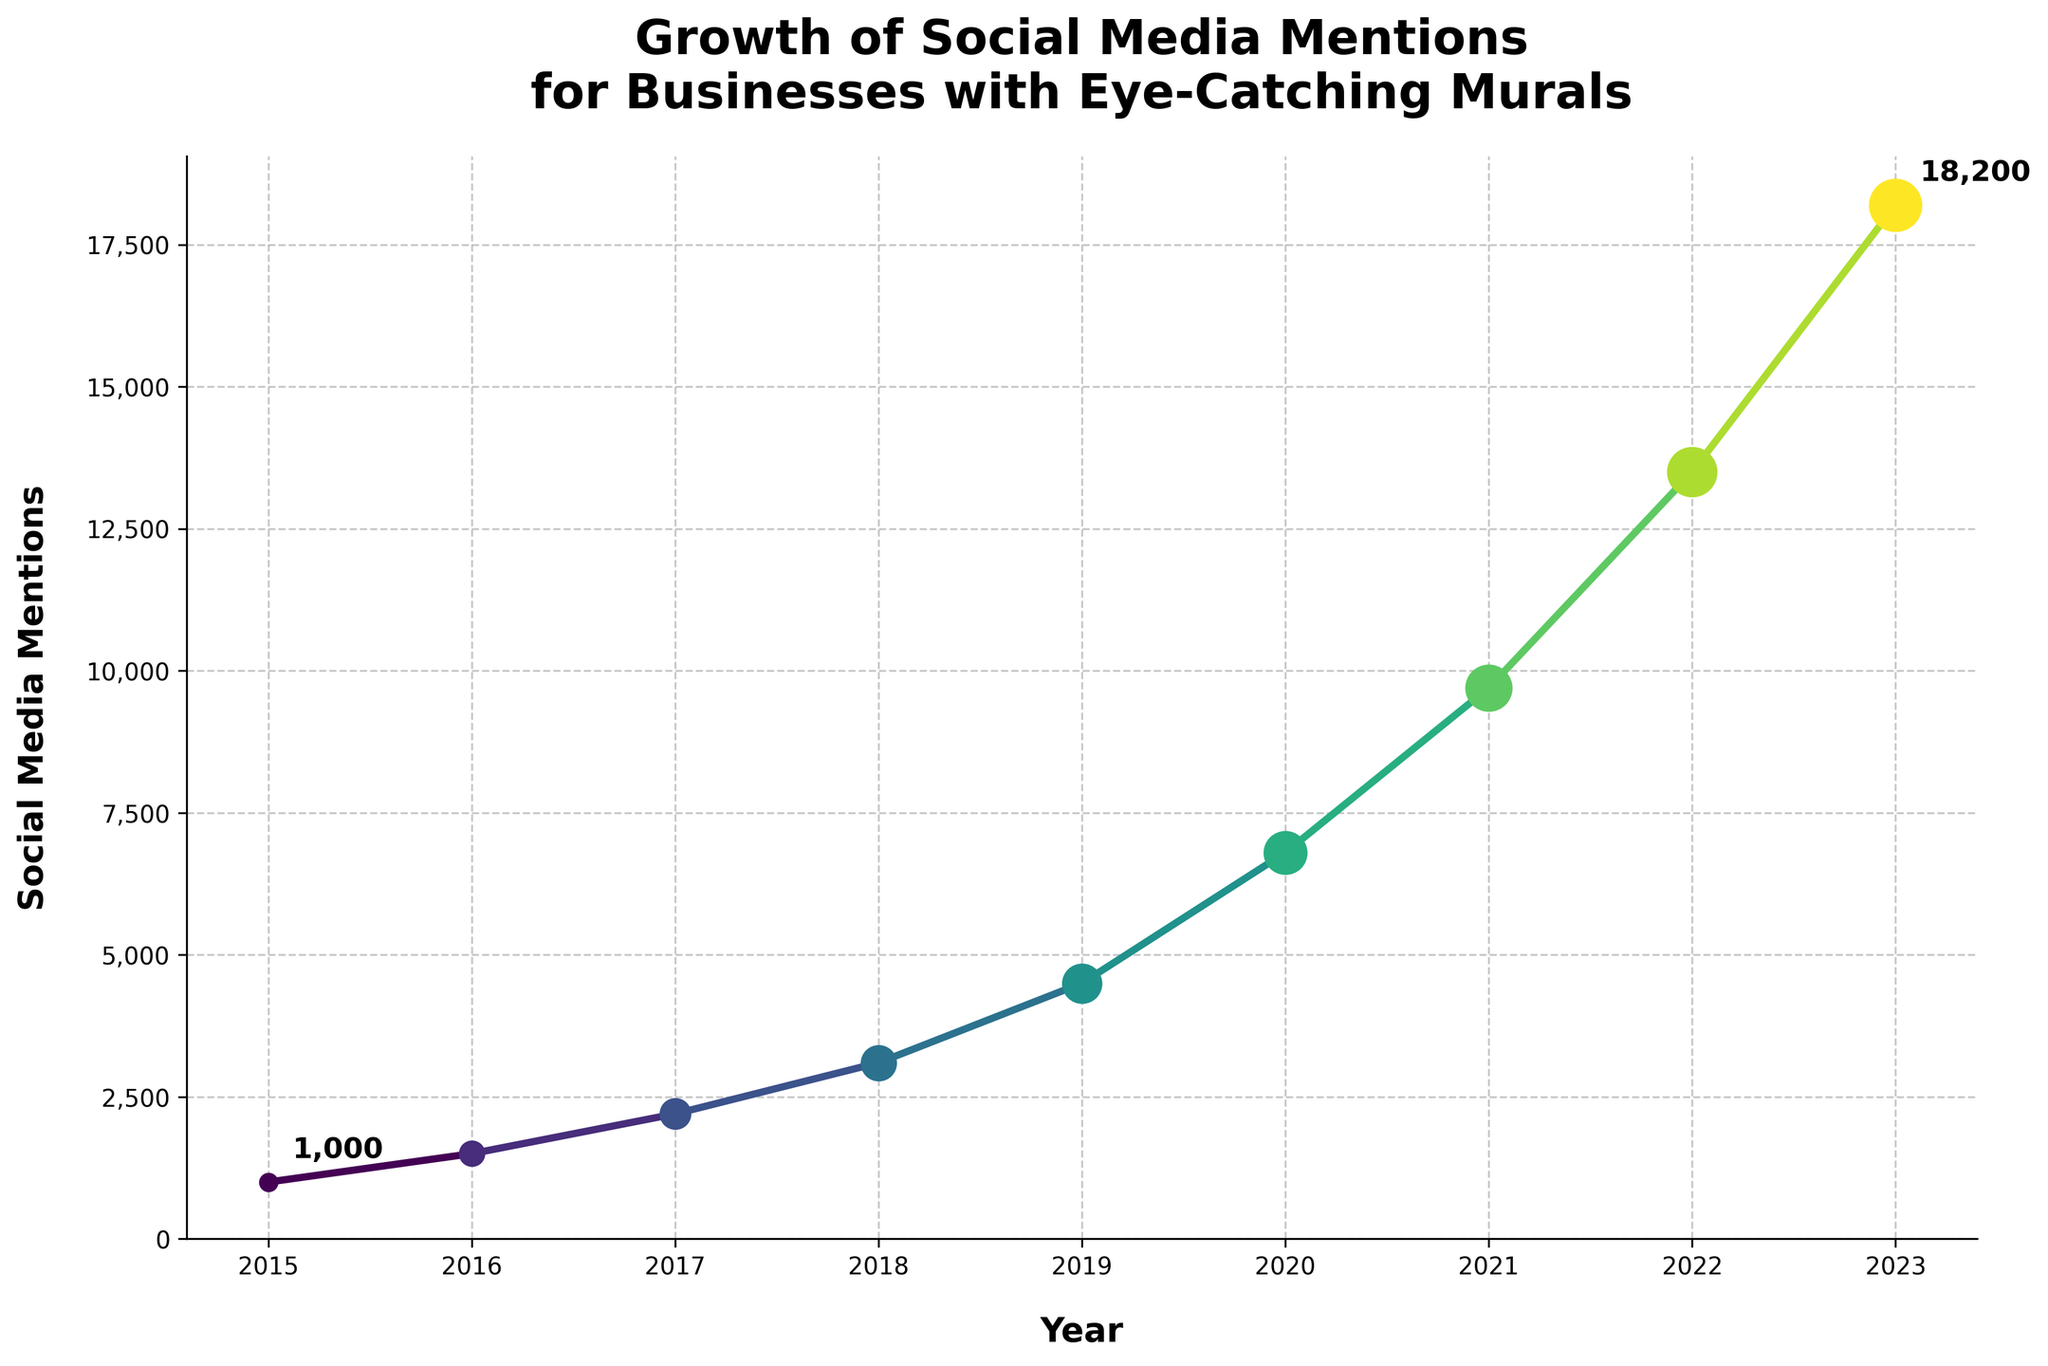What is the overall trend of social media mentions for businesses with eye-catching murals from 2015 to 2023? The plot shows a steady increase in social media mentions each year from 2015 to 2023. The number of mentions rises gradually from 1000 in 2015 to 18200 in 2023.
Answer: Increasing Which year experienced the highest increase in social media mentions compared to the previous year? By checking the differences between consecutive years, the biggest increase is between 2022 (13500 mentions) and 2023 (18200 mentions), which is a 4700 mentions increase.
Answer: 2023 How many social media mentions were there in 2018? By looking at the y-axis and the data point for the year 2018, it shows 3100 social media mentions.
Answer: 3100 Was there a year where the growth in social media mentions was less than the previous year's growth? By comparing the differences year by year, we see a continuous increase without any decrease in the growth between years. Thus, no year had lesser growth than the previous year.
Answer: No What is the mean annual increase in social media mentions from 2015 to 2023? First, calculate the annual increases: 500, 700, 900, 1400, 2300, 2900, 3800, 4700. Sum these increases, which is 17200, and divide by the number of intervals, which is 8. So, the mean annual increase is 17200/8 = 2150.
Answer: 2150 Which two consecutive years had the smallest increase in social media mentions? By comparing the year-on-year increases: 500 (2015-2016), 700 (2016-2017), 900 (2017-2018), 1400 (2018-2019), 2300 (2019-2020), 2900 (2020-2021), 3800 (2021-2022), 4700 (2022-2023), the smallest is between 2015 and 2016 with an increase of 500 mentions.
Answer: 2015-2016 How many years did it take for the social media mentions to double from 1000 to 2000? In 2015, the mentions were 1000, and by 2017 it reached 2200. Therefore, it took 2 years from 2015 to 2017 to more than double from 1000.
Answer: 2 years In what year did the social media mentions first exceed 5000? By checking the data points, 2020 is the first year where social media mentions exceeded 5000, with 6800 mentions.
Answer: 2020 Which year had mentions closest to the average number of mentions across all years? First, calculate the average: total mentions from 2015 to 2023 are 58400 over 9 years, so the average is 58400/9 = 6488. By comparing this with yearly data, 2020 with 6800 mentions is the closest.
Answer: 2020 